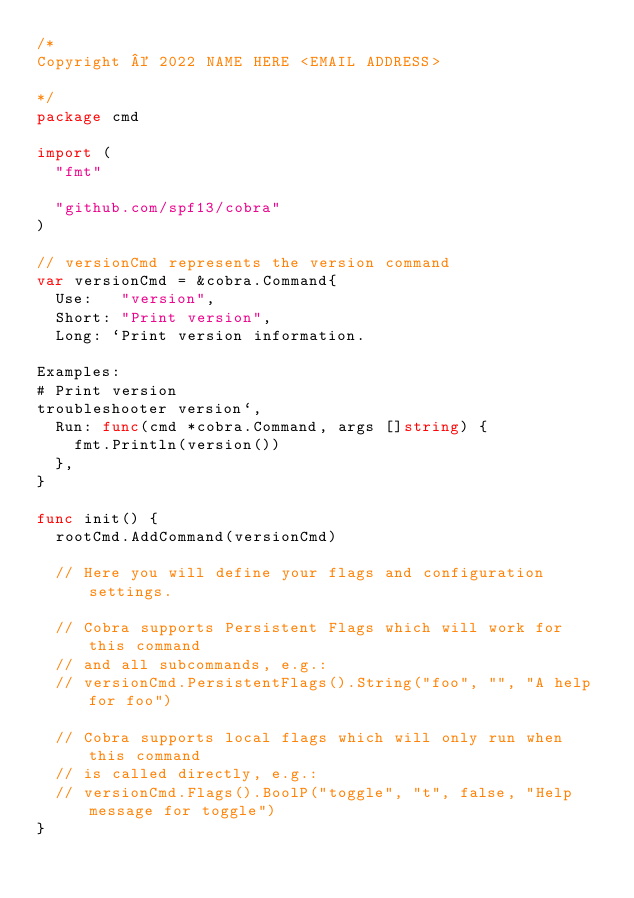<code> <loc_0><loc_0><loc_500><loc_500><_Go_>/*
Copyright © 2022 NAME HERE <EMAIL ADDRESS>

*/
package cmd

import (
	"fmt"

	"github.com/spf13/cobra"
)

// versionCmd represents the version command
var versionCmd = &cobra.Command{
	Use:   "version",
	Short: "Print version",
	Long: `Print version information. 

Examples:
# Print version
troubleshooter version`,
	Run: func(cmd *cobra.Command, args []string) {
		fmt.Println(version())
	},
}

func init() {
	rootCmd.AddCommand(versionCmd)

	// Here you will define your flags and configuration settings.

	// Cobra supports Persistent Flags which will work for this command
	// and all subcommands, e.g.:
	// versionCmd.PersistentFlags().String("foo", "", "A help for foo")

	// Cobra supports local flags which will only run when this command
	// is called directly, e.g.:
	// versionCmd.Flags().BoolP("toggle", "t", false, "Help message for toggle")
}
</code> 